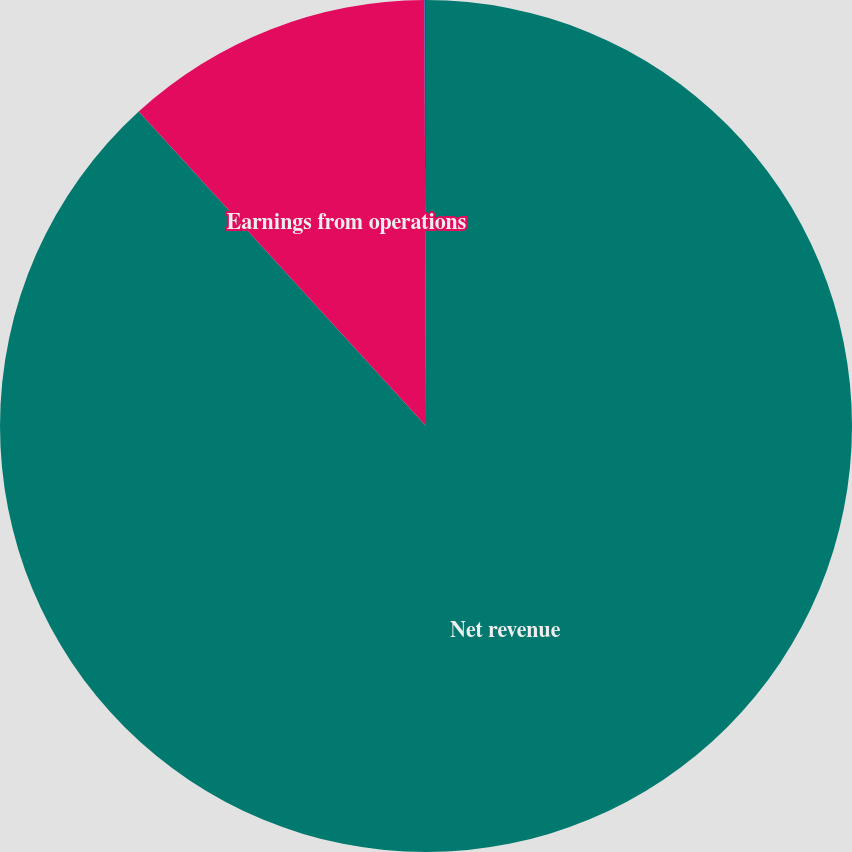Convert chart. <chart><loc_0><loc_0><loc_500><loc_500><pie_chart><fcel>Net revenue<fcel>Earnings from operations<fcel>Earnings from operations as a<nl><fcel>88.22%<fcel>11.72%<fcel>0.06%<nl></chart> 